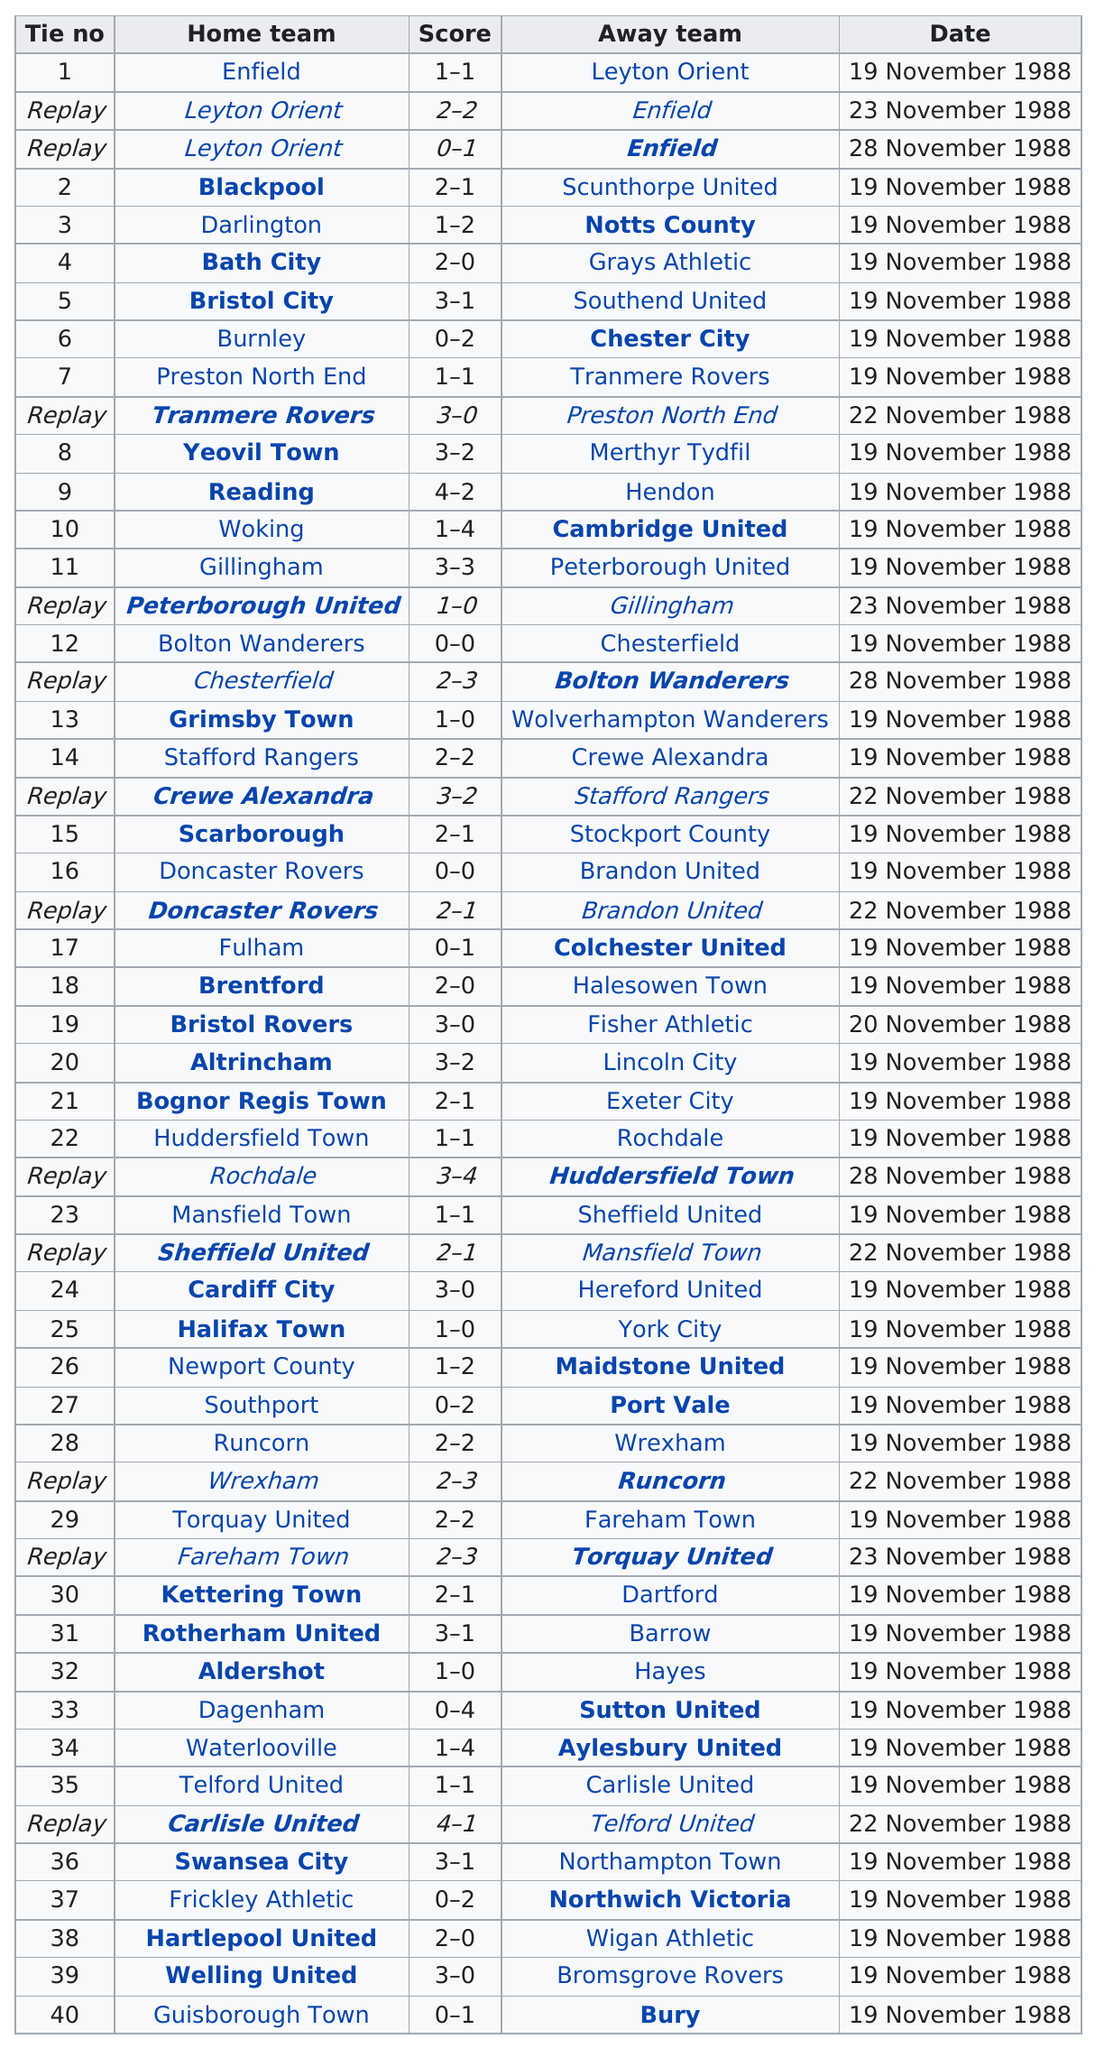Point out several critical features in this image. In the first round proper of November 1988, a total of 25 home team wins were recorded. Gillingham and Peterborough United played a total of two games in the first round proper. There exists a game that did not have any goals scored, and it had 12 players participating. Enfield and Leyton Orient played a total of three consecutive games in the first round proper of a certain competition. In the first round proper, both Darlington and Notts County participated in a tie. 